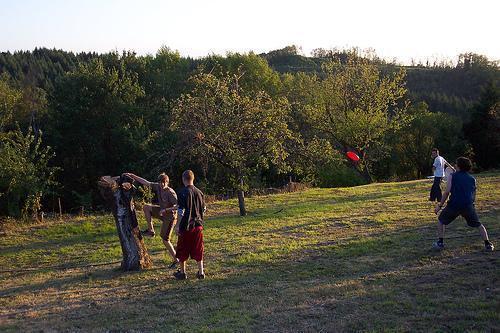How many people are there?
Give a very brief answer. 4. 